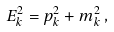<formula> <loc_0><loc_0><loc_500><loc_500>E _ { k } ^ { 2 } = p _ { k } ^ { 2 } + m _ { k } ^ { 2 } \, ,</formula> 